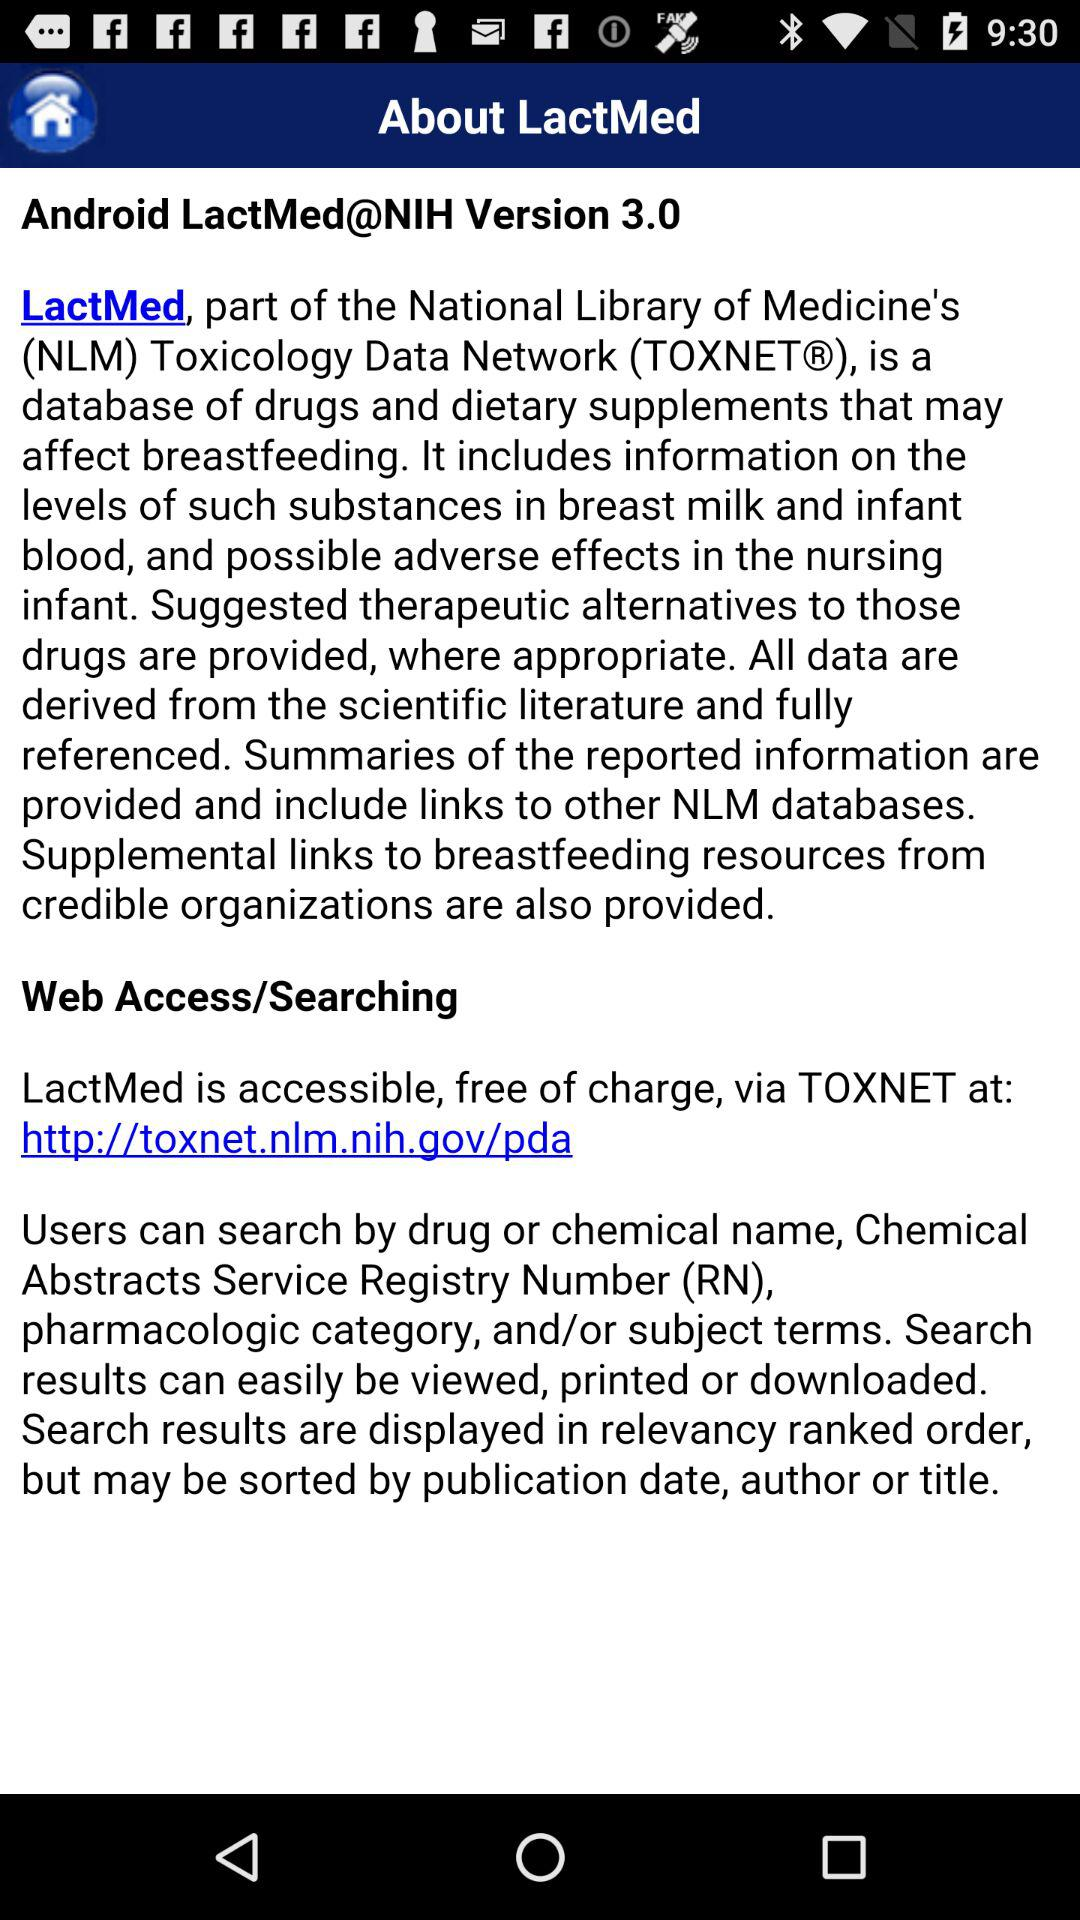What is the name of the application? The name of the application is "LectMed". 